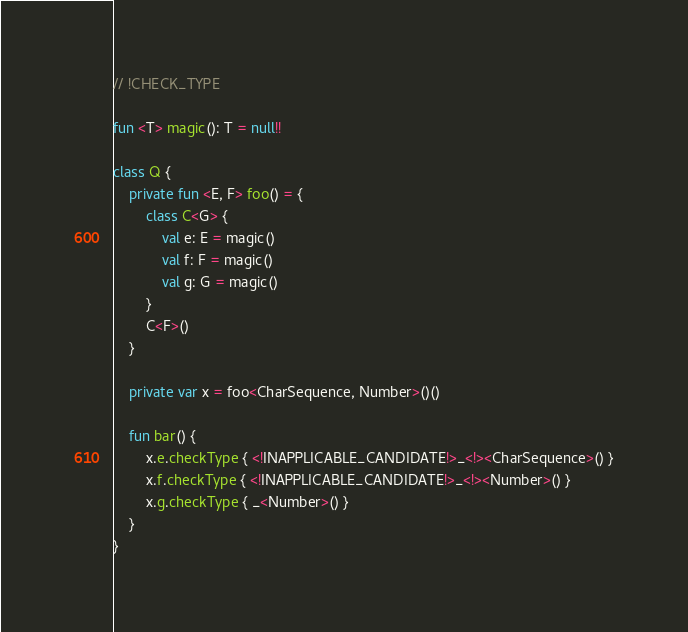Convert code to text. <code><loc_0><loc_0><loc_500><loc_500><_Kotlin_>// !CHECK_TYPE

fun <T> magic(): T = null!!

class Q {
    private fun <E, F> foo() = {
        class C<G> {
            val e: E = magic()
            val f: F = magic()
            val g: G = magic()
        }
        C<F>()
    }

    private var x = foo<CharSequence, Number>()()

    fun bar() {
        x.e.checkType { <!INAPPLICABLE_CANDIDATE!>_<!><CharSequence>() }
        x.f.checkType { <!INAPPLICABLE_CANDIDATE!>_<!><Number>() }
        x.g.checkType { _<Number>() }
    }
}
</code> 